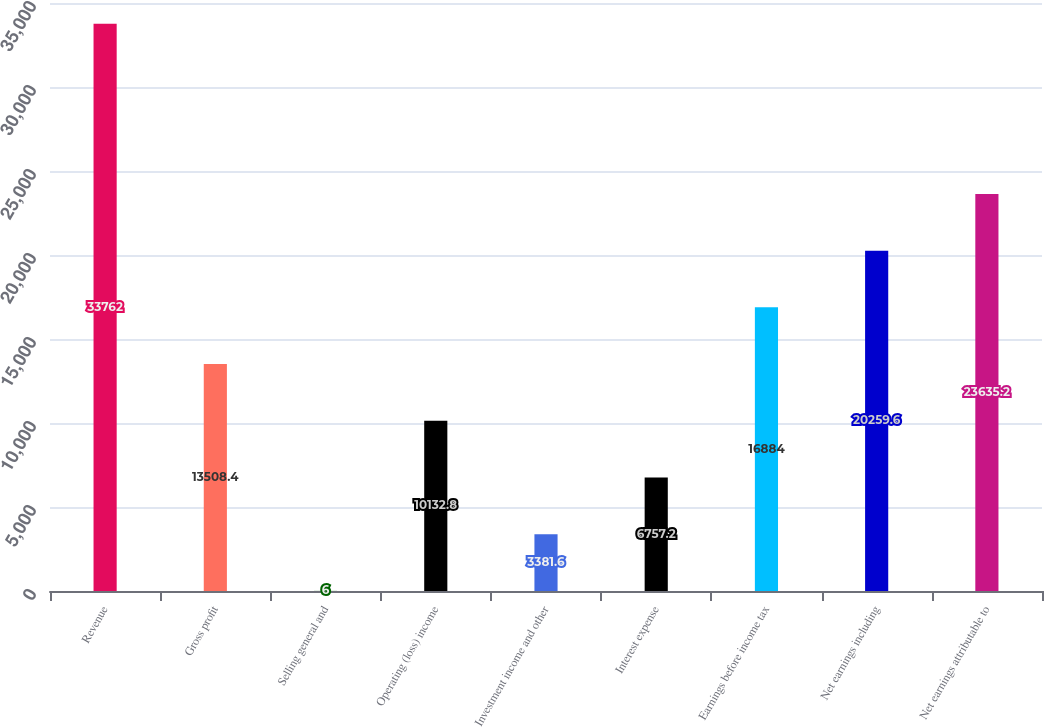<chart> <loc_0><loc_0><loc_500><loc_500><bar_chart><fcel>Revenue<fcel>Gross profit<fcel>Selling general and<fcel>Operating (loss) income<fcel>Investment income and other<fcel>Interest expense<fcel>Earnings before income tax<fcel>Net earnings including<fcel>Net earnings attributable to<nl><fcel>33762<fcel>13508.4<fcel>6<fcel>10132.8<fcel>3381.6<fcel>6757.2<fcel>16884<fcel>20259.6<fcel>23635.2<nl></chart> 